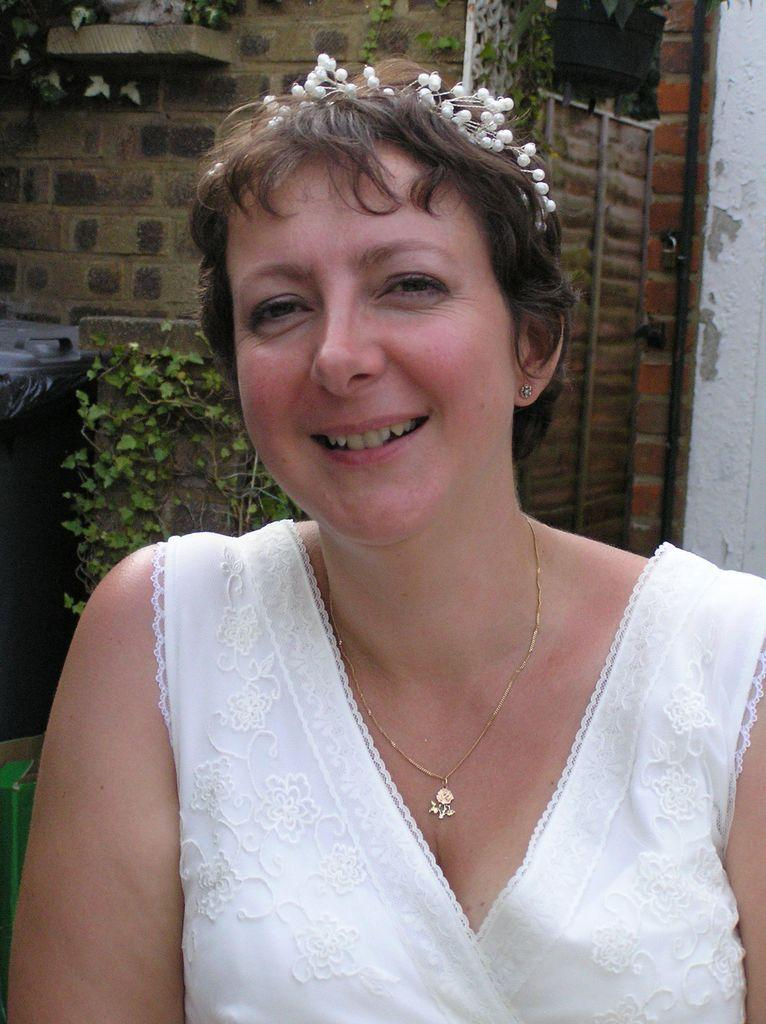Who is present in the image? There is a woman in the image. What is the woman wearing? The woman is wearing a white dress. What expression does the woman have? The woman is smiling. What can be seen in the background of the image? There is a wall with pipes in the background of the image. What is attached to the wall? There is a plant on the wall. What is located in front of the wall? There is a plant and a dustbin in front of the wall. What type of knowledge is the woman sharing with her account in the image? There is no indication in the image that the woman is sharing knowledge or using an account. 